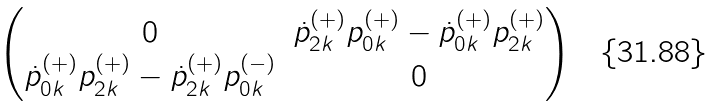<formula> <loc_0><loc_0><loc_500><loc_500>\begin{pmatrix} 0 & \dot { p } _ { 2 { k } } ^ { ( + ) } p _ { 0 { k } } ^ { ( + ) } - \dot { p } _ { 0 { k } } ^ { ( + ) } p _ { 2 { k } } ^ { ( + ) } \\ \dot { p } _ { 0 { k } } ^ { ( + ) } p _ { 2 { k } } ^ { ( + ) } - \dot { p } _ { 2 { k } } ^ { ( + ) } p _ { 0 { k } } ^ { ( - ) } & 0 \end{pmatrix}</formula> 